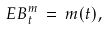<formula> <loc_0><loc_0><loc_500><loc_500>E B _ { t } ^ { m } \, = \, m ( t ) ,</formula> 